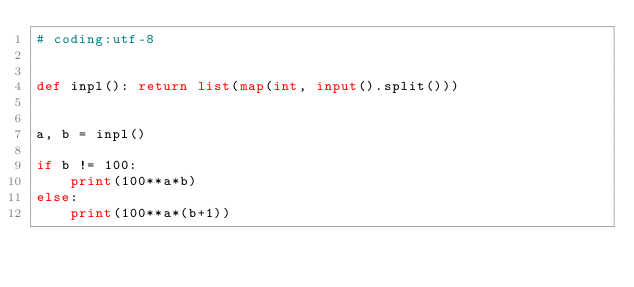Convert code to text. <code><loc_0><loc_0><loc_500><loc_500><_Python_># coding:utf-8


def inpl(): return list(map(int, input().split()))


a, b = inpl()

if b != 100:
    print(100**a*b)
else:
    print(100**a*(b+1))</code> 